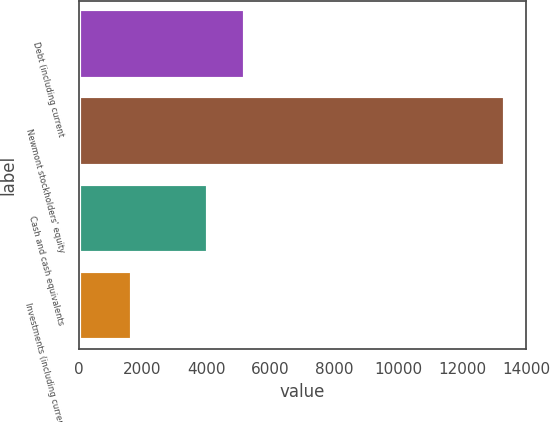Convert chart. <chart><loc_0><loc_0><loc_500><loc_500><bar_chart><fcel>Debt (including current<fcel>Newmont stockholders' equity<fcel>Cash and cash equivalents<fcel>Investments (including current<nl><fcel>5222.4<fcel>13345<fcel>4056<fcel>1681<nl></chart> 